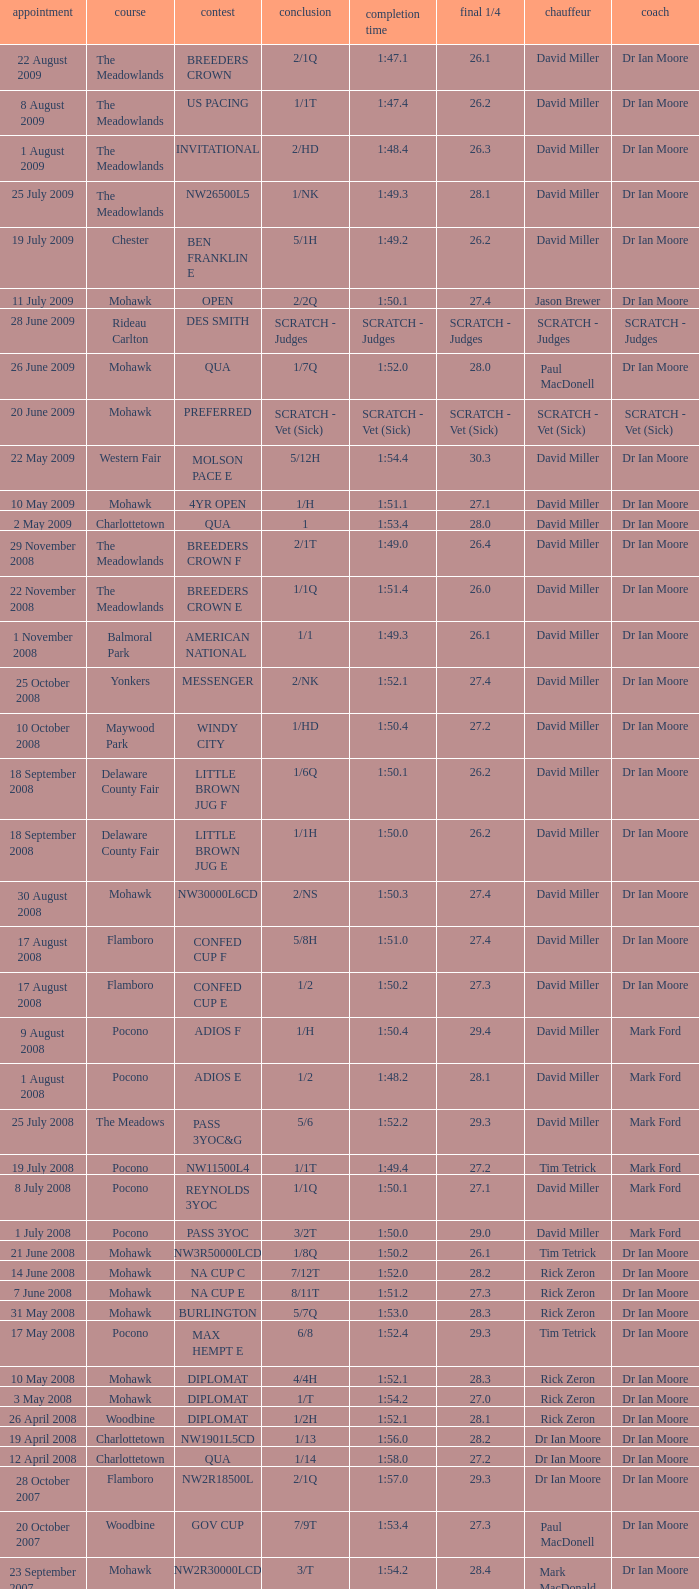What is the last 1/4 for the QUA race with a finishing time of 2:03.1? 29.2. 